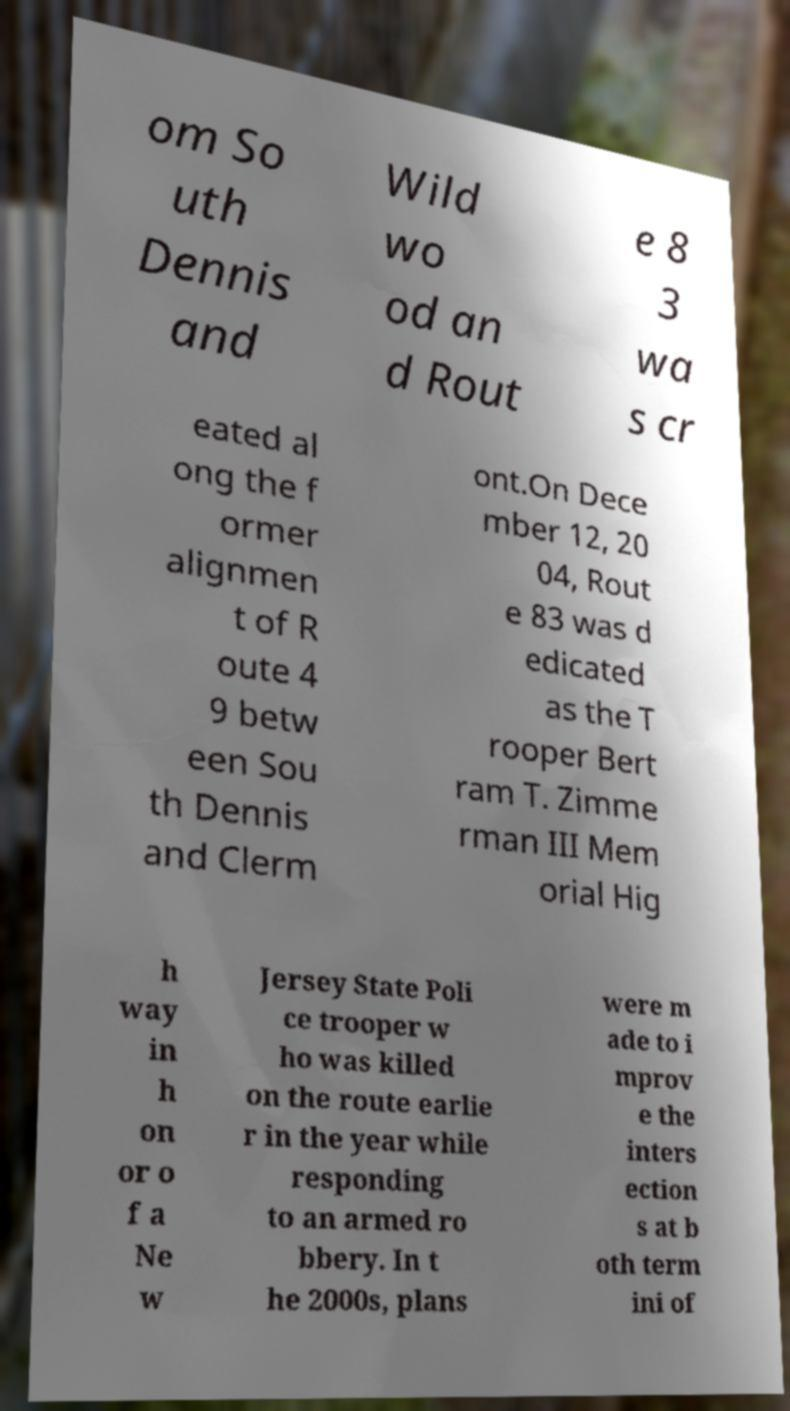I need the written content from this picture converted into text. Can you do that? om So uth Dennis and Wild wo od an d Rout e 8 3 wa s cr eated al ong the f ormer alignmen t of R oute 4 9 betw een Sou th Dennis and Clerm ont.On Dece mber 12, 20 04, Rout e 83 was d edicated as the T rooper Bert ram T. Zimme rman III Mem orial Hig h way in h on or o f a Ne w Jersey State Poli ce trooper w ho was killed on the route earlie r in the year while responding to an armed ro bbery. In t he 2000s, plans were m ade to i mprov e the inters ection s at b oth term ini of 